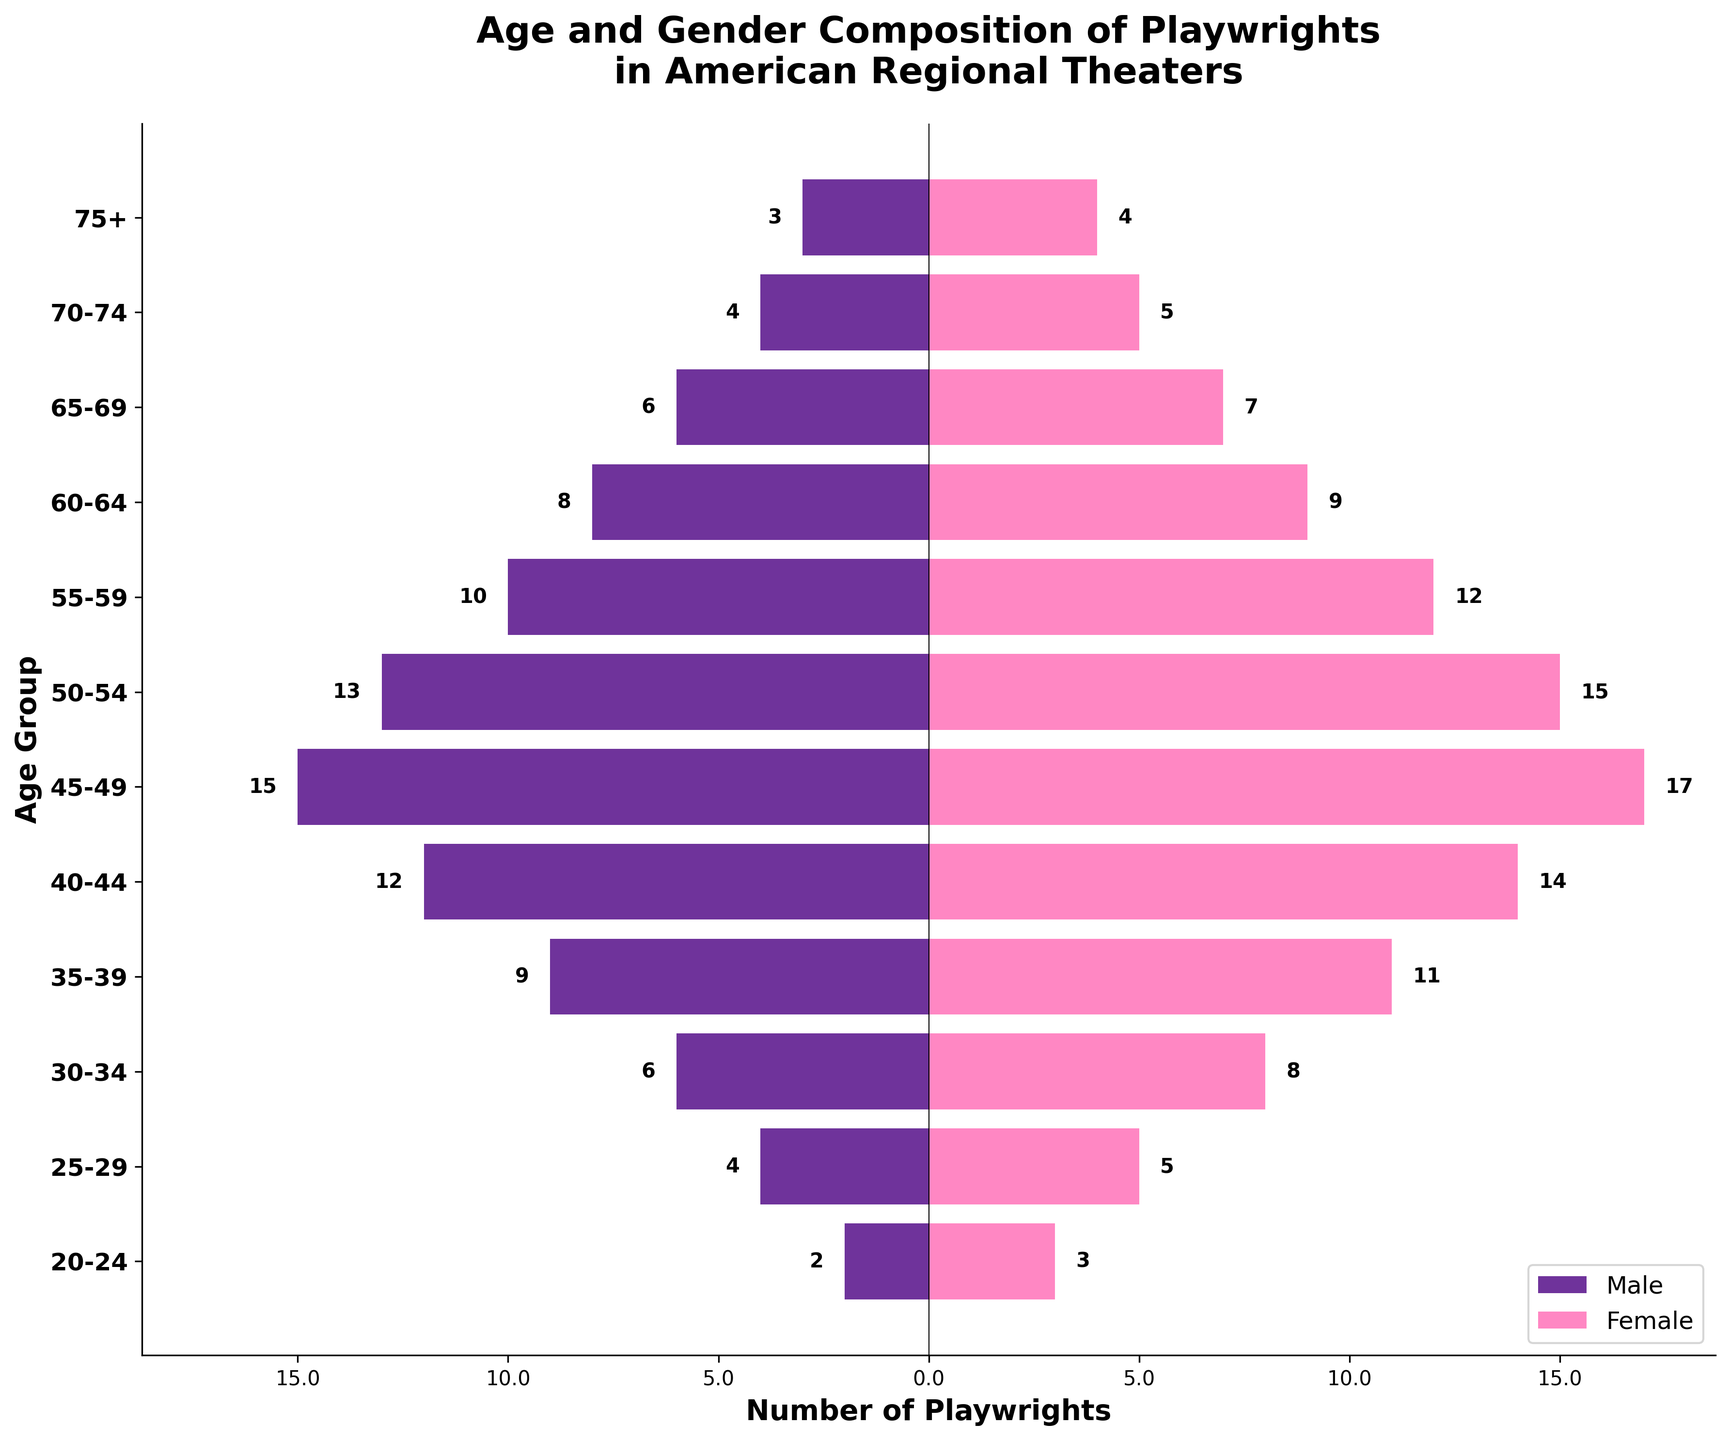What is the title of the plot? The title is located at the top center of the plot. It is displayed in a larger, bold font.
Answer: Age and Gender Composition of Playwrights in American Regional Theaters What is the total number of female playwrights in the 35-39 age group? The figure shows bars representing the number of male and female playwrights by age group. The bar for females in the 35-39 age group extends to 11.
Answer: 11 Which age group has the highest number of male playwrights? To determine this, we look at the length of the bars for male playwrights (negative x-axis) and identify the longest one. The bar for males in the 45-49 age group is the longest.
Answer: 45-49 How many more female playwrights are there in the 40-44 age group compared to male playwrights in the same group? Identify the number of female playwrights (14) and male playwrights (12) in the 40-44 age group and subtract the two values: 14 - 12 = 2.
Answer: 2 What is the total number of playwrights aged 60-64? Add the number of male (8) and female (9) playwrights in the 60-64 age group: 8 + 9 = 17.
Answer: 17 Compare the number of male and female playwrights in the 25-29 age group. Who is more, and by how much? Check the number of male (4) and female (5) playwrights in the 25-29 age group. Female playwrights are more by 1: 5 - 4 = 1.
Answer: Female by 1 Which age group has an equal number of male and female playwrights? Scan the figure for age groups where the bars for male and female playwrights are of the same length. The bars for the 75+ age group are equally long for both males (3) and females (4).
Answer: None have an equal number What is the total number of playwrights in the 50-54 age group? Summing the number of male (13) and female (15) playwrights in the 50-54 age group: 13 + 15 = 28.
Answer: 28 How does the number of 20-24-year-old female playwrights compare to 70-74-year-old male playwrights? Identify the number of female playwrights aged 20-24 (3) and male playwrights aged 70-74 (4). Compare: 4 is greater than 3.
Answer: 70-74-year-old males are more by 1 What is the trend observed in the number of playwrights as age increases from 20-75+ for both genders? Observe the changes in bar lengths for both genders from 20-24 to 75+. Generally, the number of playwrights for both genders increases up to middle age (45-49) and then decreases.
Answer: Increases up to 45-49, then decreases 